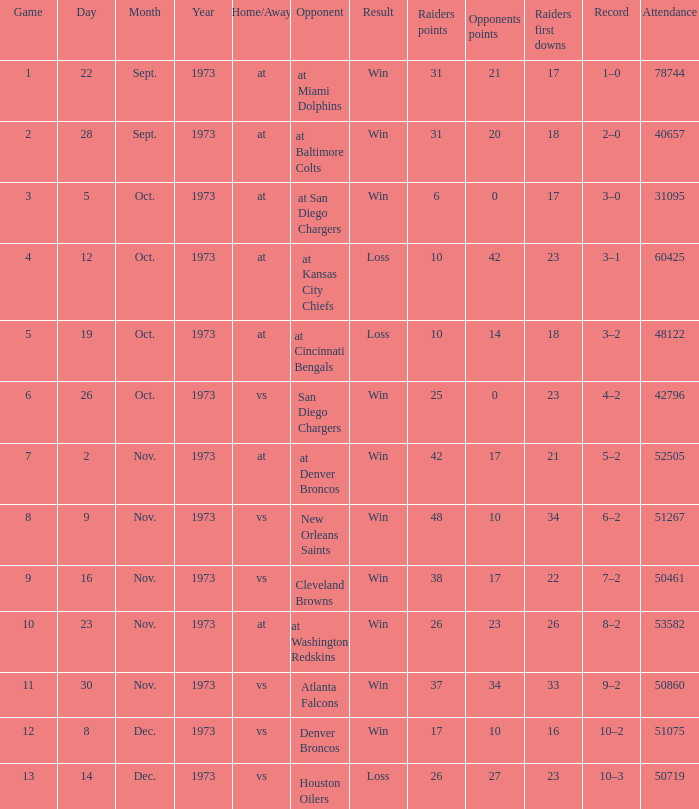What's the record in the game played against 42? 3–1. Can you give me this table as a dict? {'header': ['Game', 'Day', 'Month', 'Year', 'Home/Away', 'Opponent', 'Result', 'Raiders points', 'Opponents points', 'Raiders first downs', 'Record', 'Attendance'], 'rows': [['1', '22', 'Sept.', '1973', 'at', 'at Miami Dolphins', 'Win', '31', '21', '17', '1–0', '78744'], ['2', '28', 'Sept.', '1973', 'at', 'at Baltimore Colts', 'Win', '31', '20', '18', '2–0', '40657'], ['3', '5', 'Oct.', '1973', 'at', 'at San Diego Chargers', 'Win', '6', '0', '17', '3–0', '31095'], ['4', '12', 'Oct.', '1973', 'at', 'at Kansas City Chiefs', 'Loss', '10', '42', '23', '3–1', '60425'], ['5', '19', 'Oct.', '1973', 'at', 'at Cincinnati Bengals', 'Loss', '10', '14', '18', '3–2', '48122'], ['6', '26', 'Oct.', '1973', 'vs', 'San Diego Chargers', 'Win', '25', '0', '23', '4–2', '42796'], ['7', '2', 'Nov.', '1973', 'at', 'at Denver Broncos', 'Win', '42', '17', '21', '5–2', '52505'], ['8', '9', 'Nov.', '1973', 'vs', 'New Orleans Saints', 'Win', '48', '10', '34', '6–2', '51267'], ['9', '16', 'Nov.', '1973', 'vs', 'Cleveland Browns', 'Win', '38', '17', '22', '7–2', '50461'], ['10', '23', 'Nov.', '1973', 'at', 'at Washington Redskins', 'Win', '26', '23', '26', '8–2', '53582'], ['11', '30', 'Nov.', '1973', 'vs', 'Atlanta Falcons', 'Win', '37', '34', '33', '9–2', '50860'], ['12', '8', 'Dec.', '1973', 'vs', 'Denver Broncos', 'Win', '17', '10', '16', '10–2', '51075'], ['13', '14', 'Dec.', '1973', 'vs', 'Houston Oilers', 'Loss', '26', '27', '23', '10–3', '50719']]} 